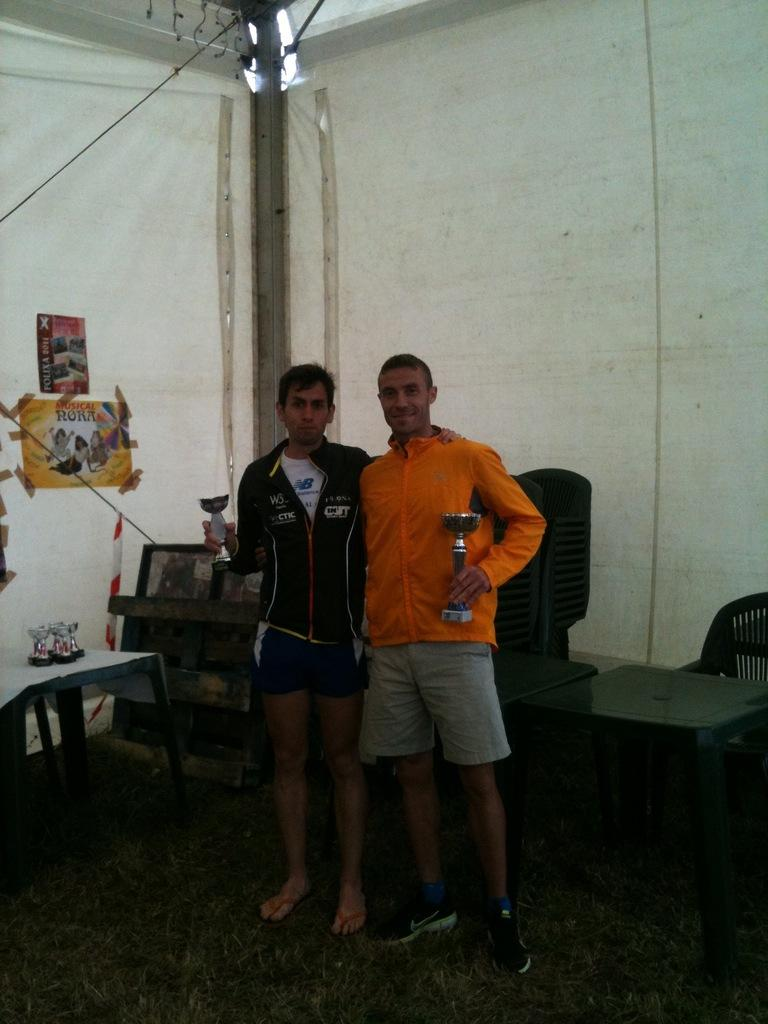How many people are in the image? There are two men in the image. What are the men doing in the image? The men are standing and smiling. What type of clothing are the men wearing? The men are wearing coats and shorts. What can be seen on the left side of the image? There is a paper stuck to the wall on the left side of the image. What furniture is visible in the image? There is a chair on the right side of the image and a table in the image. What type of grain is being harvested by the men in the image? There is no grain or harvesting activity present in the image; the men are simply standing and smiling. Can you tell me how many laps the men have swum in the image? There is no swimming or laps being swum in the image; the men are wearing coats and shorts while standing. 